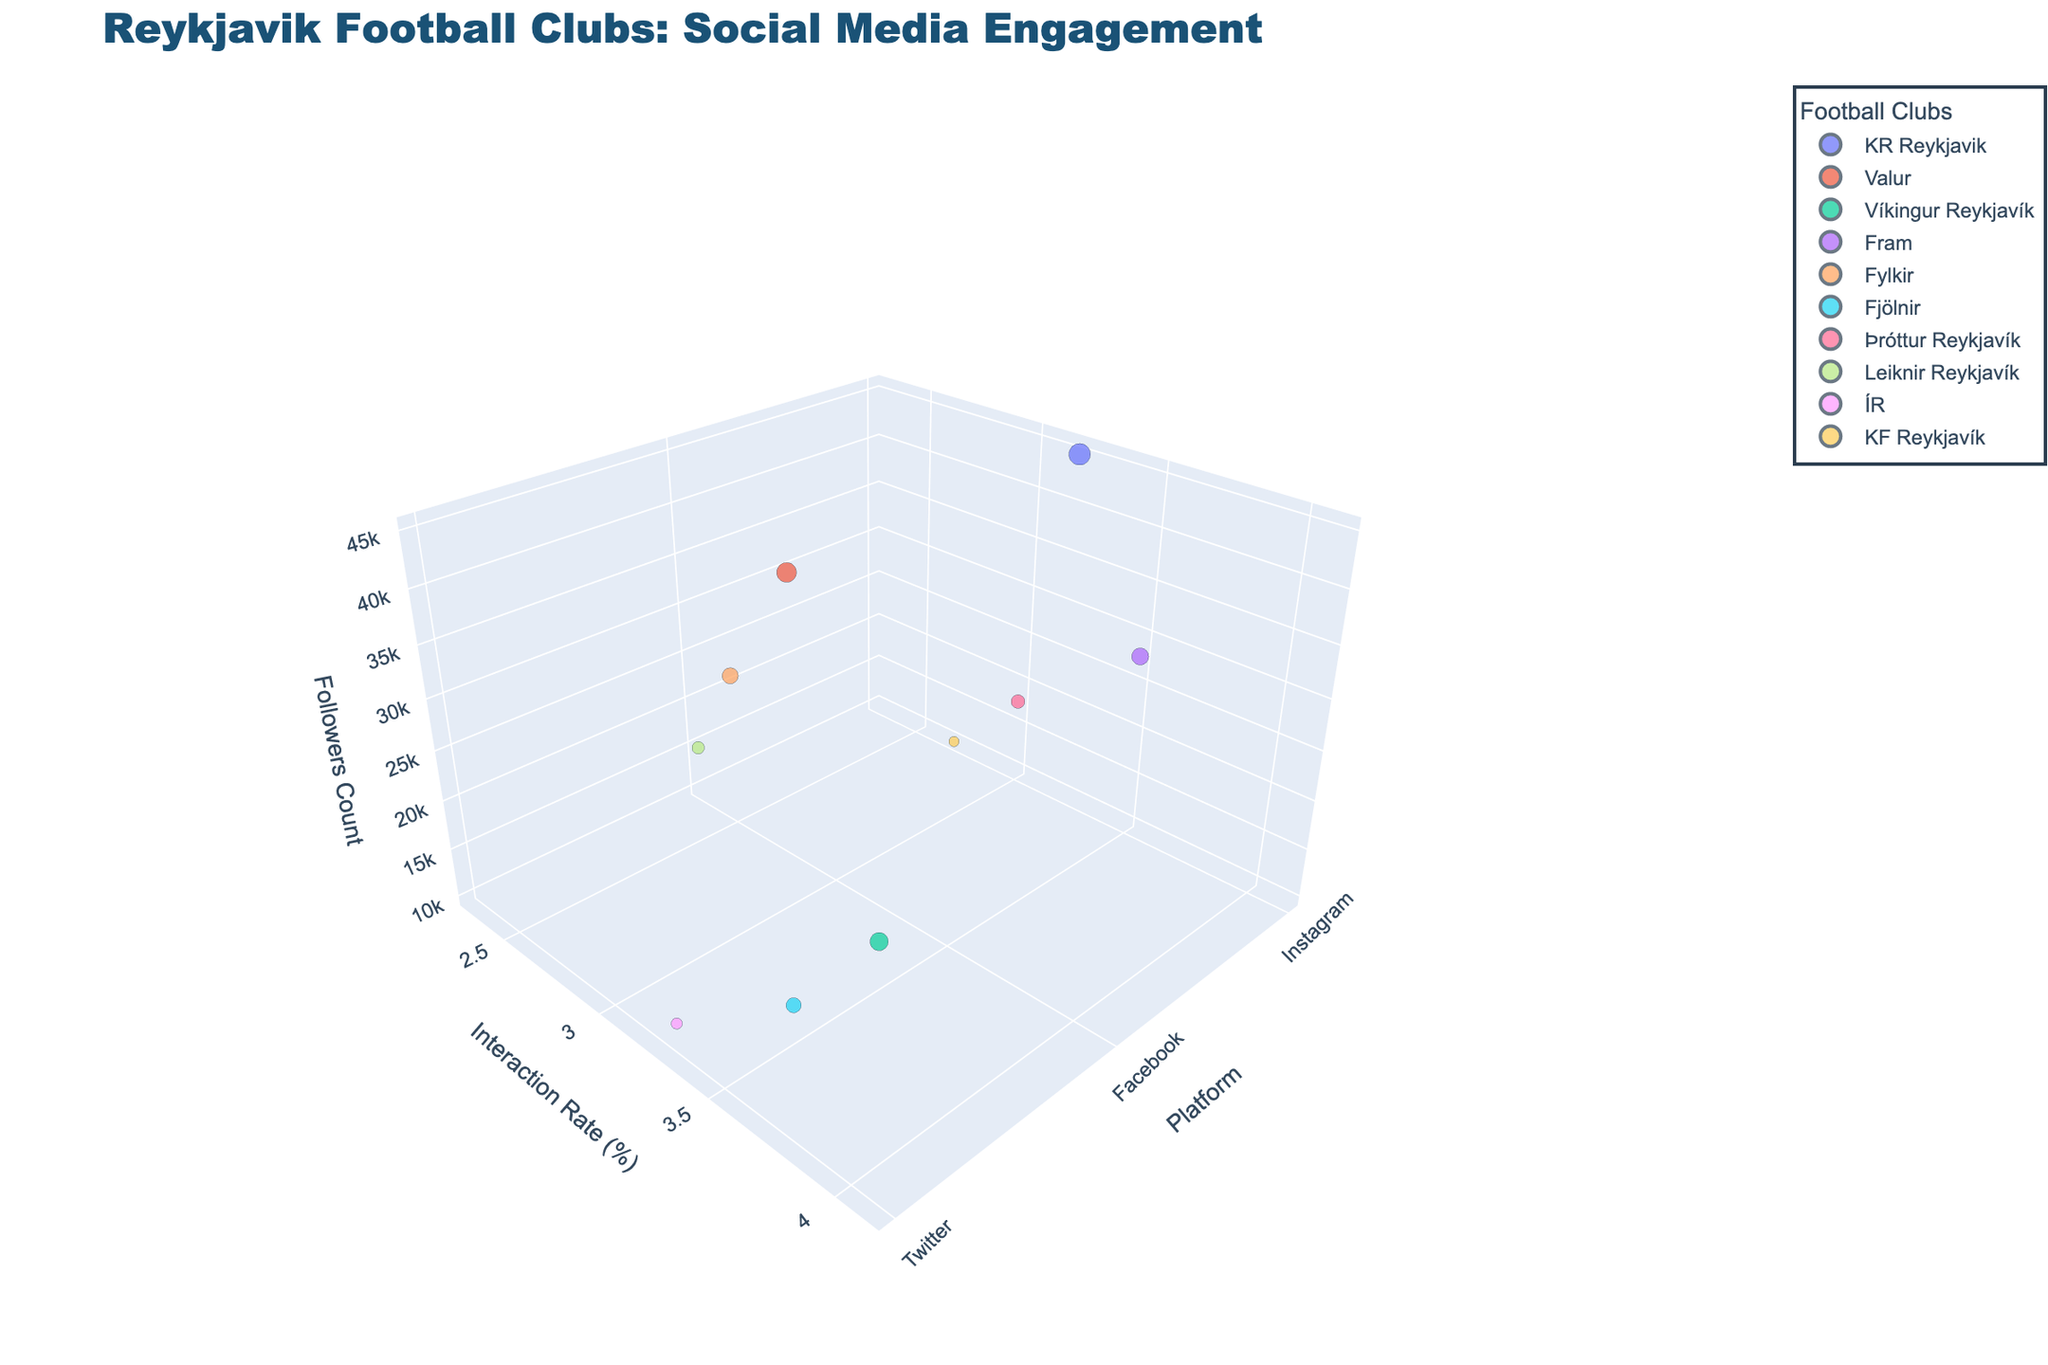What's the title of the figure? The title is usually displayed prominently at the top of the figure, summarizing its purpose. It can be identified by its larger and bold font.
Answer: Reykjavik Football Clubs: Social Media Engagement Which club has the highest number of followers? In the figure, the z-axis represents the number of followers. The club with the highest point on this axis has the most followers. By looking at the highest point, we can see that KR Reykjavik has the most followers.
Answer: KR Reykjavik What is the content type with the highest interaction rate? The y-axis represents the interaction rate. By finding the highest point on this axis and checking the associated content type, we can see that Víkingur Reykjavík, with Live Commentary, has the highest interaction rate of 4.1%.
Answer: Live Commentary Which platform shows the lowest interaction rate? To determine this, we need to look along the y-axis and find the lowest point. From the chart, Leiknir Reykjavík on Facebook shows the lowest interaction rate at 2.3%.
Answer: Facebook How many clubs are featured in the figure? Each bubble represents a different club. By counting the unique clubs shown in the legend, we can determine the number of clubs.
Answer: 10 Which club has the smallest bubble size on Instagram? Bubble size corresponds to 'BubbleSize'. By examining the Instagram category and comparing the bubble sizes, we can see that KF Reykjavík has the smallest bubble size on Instagram (size 10).
Answer: KF Reykjavík What is the average number of followers for clubs on Facebook? There are 3 clubs on Facebook with followers counts of 38000, 25000, and 15000. Summing these gives 78000, and dividing by the number of clubs (3) gives the average: 78000 / 3 = 26000.
Answer: 26000 Compare the interaction rates between KR Reykjavik and Fram. Which one is higher? The interaction rates for these two clubs can be found along the y-axis. KR Reykjavik has an interaction rate of 3.2%, while Fram has 3.5%. Thus, Fram has a higher interaction rate.
Answer: Fram Which club on Twitter focuses on Youth Academy content? The content type can be identified in the hover data or by categorizing the clubs under the Twitter platform. Checking these reveals ÍR focuses on Youth Academy content on Twitter.
Answer: ÍR Which club has more followers: Fjölnir or Valur? Comparing the points on the z-axis for Fjölnir and Valur, we see Valur has 38000 followers, while Fjölnir has 22000. So, Valur has more followers.
Answer: Valur 